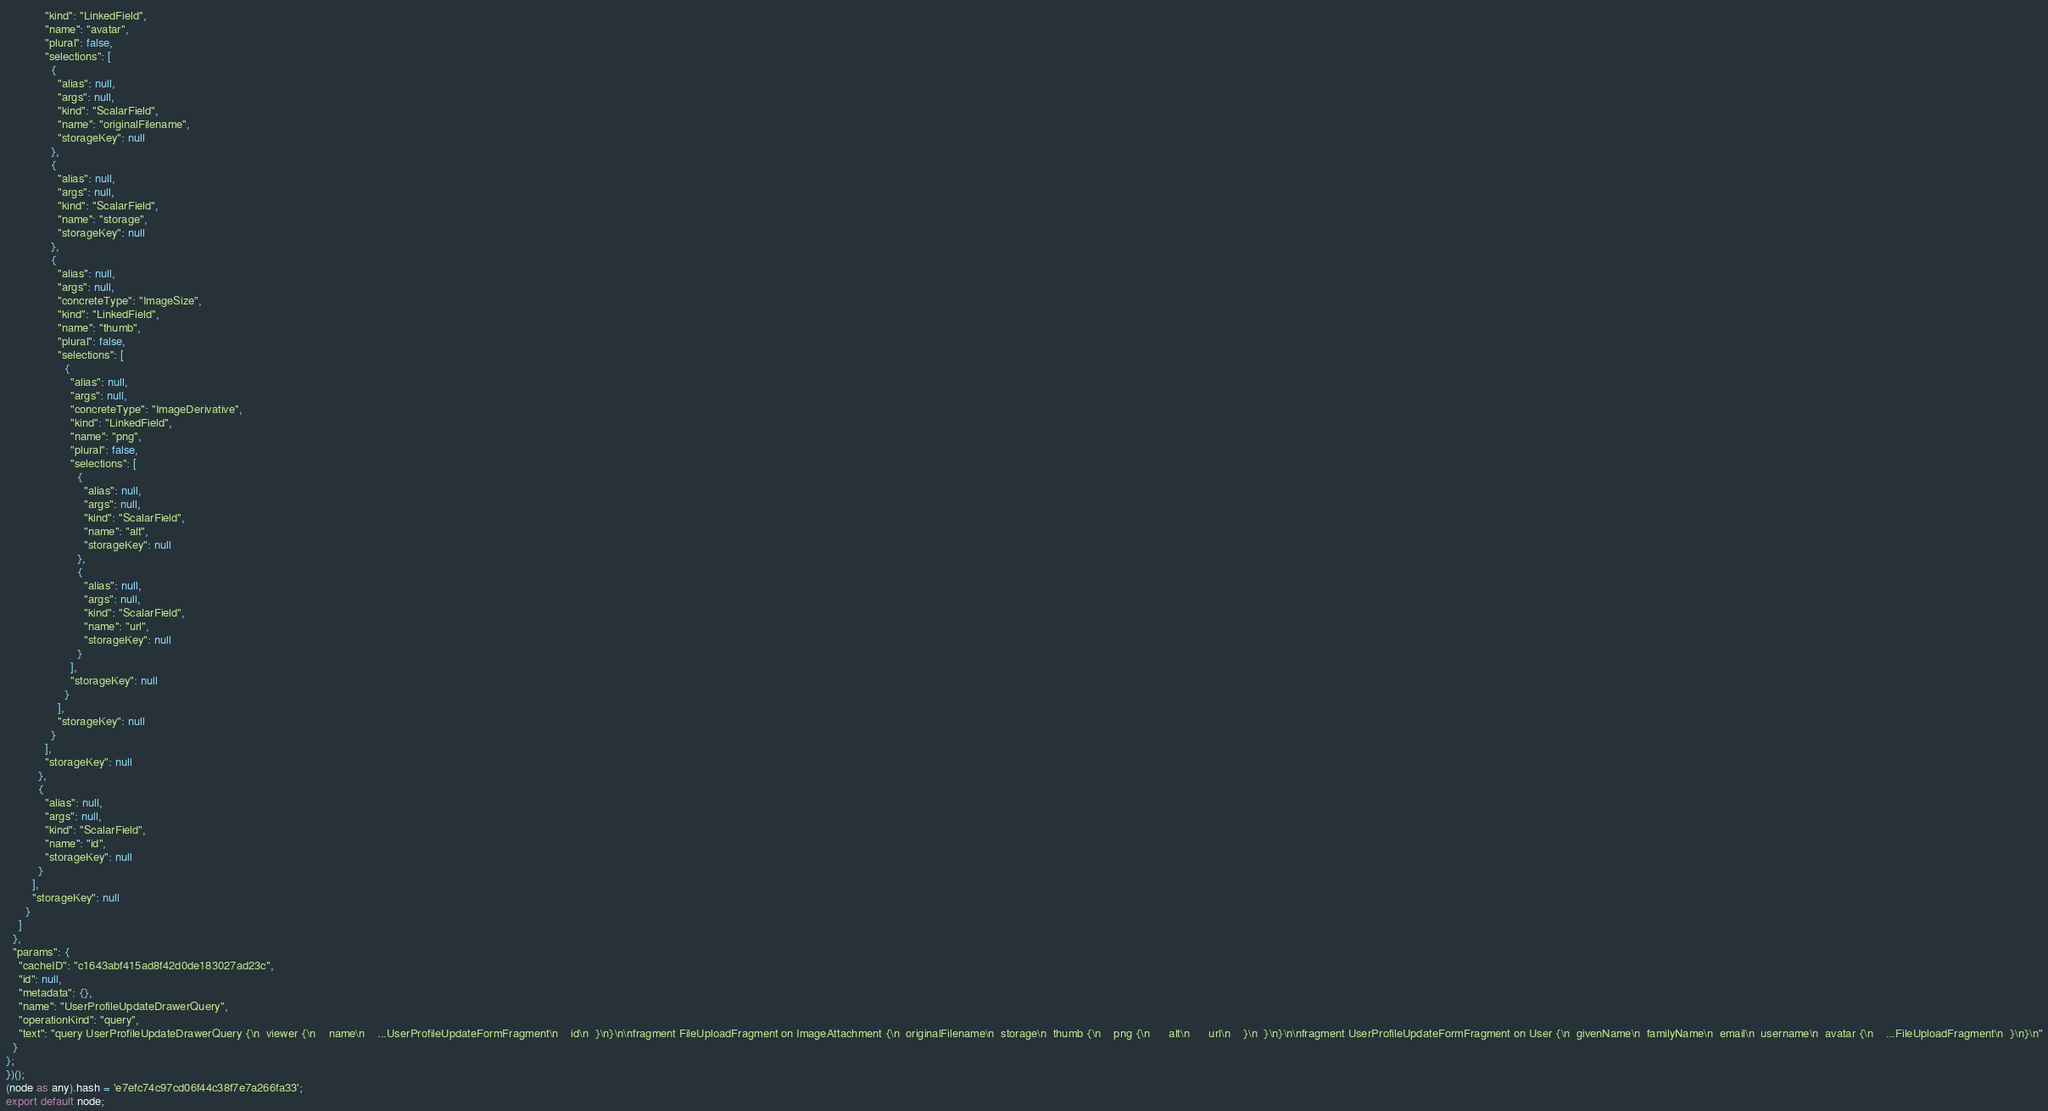<code> <loc_0><loc_0><loc_500><loc_500><_TypeScript_>            "kind": "LinkedField",
            "name": "avatar",
            "plural": false,
            "selections": [
              {
                "alias": null,
                "args": null,
                "kind": "ScalarField",
                "name": "originalFilename",
                "storageKey": null
              },
              {
                "alias": null,
                "args": null,
                "kind": "ScalarField",
                "name": "storage",
                "storageKey": null
              },
              {
                "alias": null,
                "args": null,
                "concreteType": "ImageSize",
                "kind": "LinkedField",
                "name": "thumb",
                "plural": false,
                "selections": [
                  {
                    "alias": null,
                    "args": null,
                    "concreteType": "ImageDerivative",
                    "kind": "LinkedField",
                    "name": "png",
                    "plural": false,
                    "selections": [
                      {
                        "alias": null,
                        "args": null,
                        "kind": "ScalarField",
                        "name": "alt",
                        "storageKey": null
                      },
                      {
                        "alias": null,
                        "args": null,
                        "kind": "ScalarField",
                        "name": "url",
                        "storageKey": null
                      }
                    ],
                    "storageKey": null
                  }
                ],
                "storageKey": null
              }
            ],
            "storageKey": null
          },
          {
            "alias": null,
            "args": null,
            "kind": "ScalarField",
            "name": "id",
            "storageKey": null
          }
        ],
        "storageKey": null
      }
    ]
  },
  "params": {
    "cacheID": "c1643abf415ad8f42d0de183027ad23c",
    "id": null,
    "metadata": {},
    "name": "UserProfileUpdateDrawerQuery",
    "operationKind": "query",
    "text": "query UserProfileUpdateDrawerQuery {\n  viewer {\n    name\n    ...UserProfileUpdateFormFragment\n    id\n  }\n}\n\nfragment FileUploadFragment on ImageAttachment {\n  originalFilename\n  storage\n  thumb {\n    png {\n      alt\n      url\n    }\n  }\n}\n\nfragment UserProfileUpdateFormFragment on User {\n  givenName\n  familyName\n  email\n  username\n  avatar {\n    ...FileUploadFragment\n  }\n}\n"
  }
};
})();
(node as any).hash = 'e7efc74c97cd06f44c38f7e7a266fa33';
export default node;
</code> 